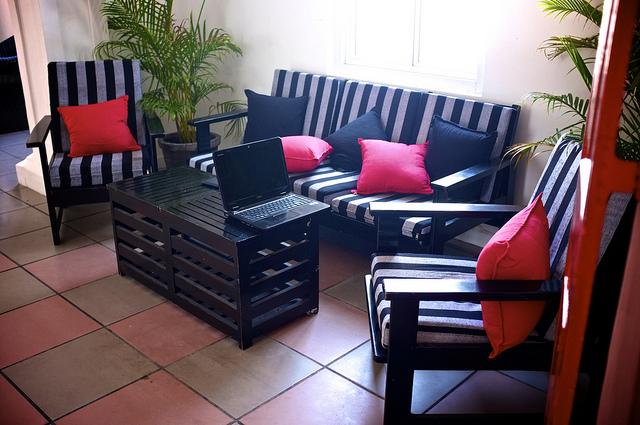Is this modern design living space?
Keep it brief. Yes. Is the fabric on the furniture a solid color?
Answer briefly. No. How many tables are in the room?
Give a very brief answer. 1. 